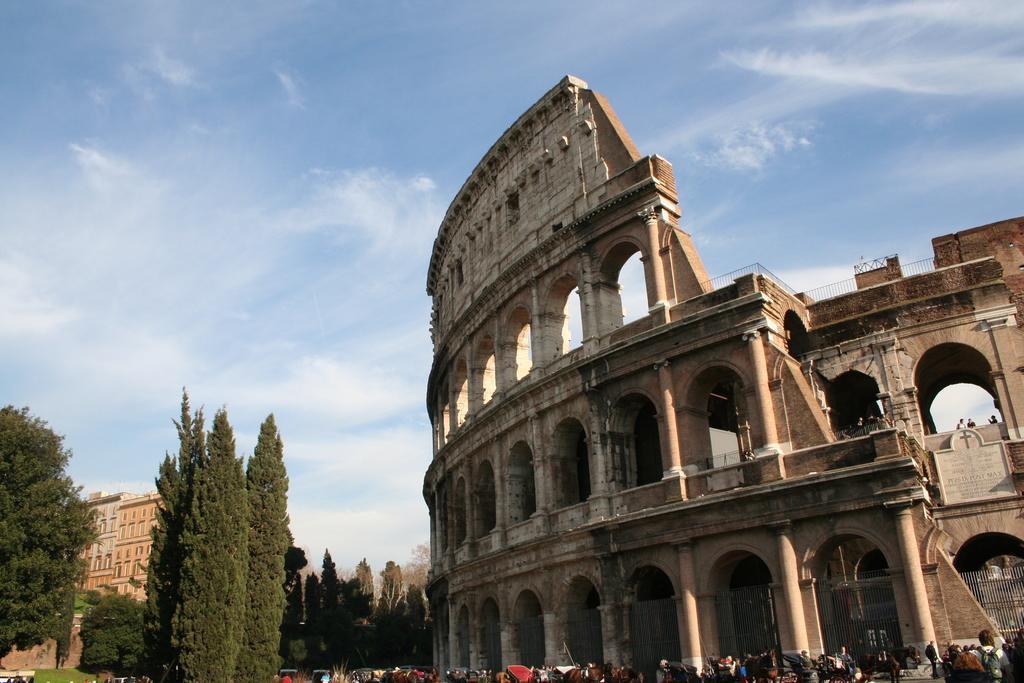Please provide a concise description of this image. As we can see in the image there are buildings, trees, few people here and there, sky and clouds. 